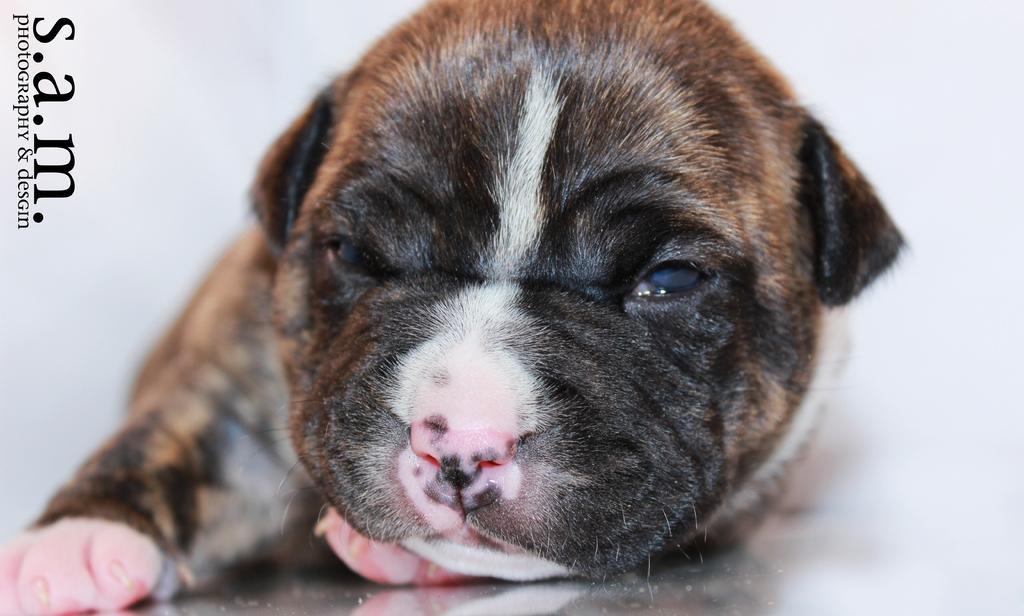Describe this image in one or two sentences. In this image, we can see a dog lying on the surface. The background is in white color. In the top left side of the image, we can see the watermarks. 